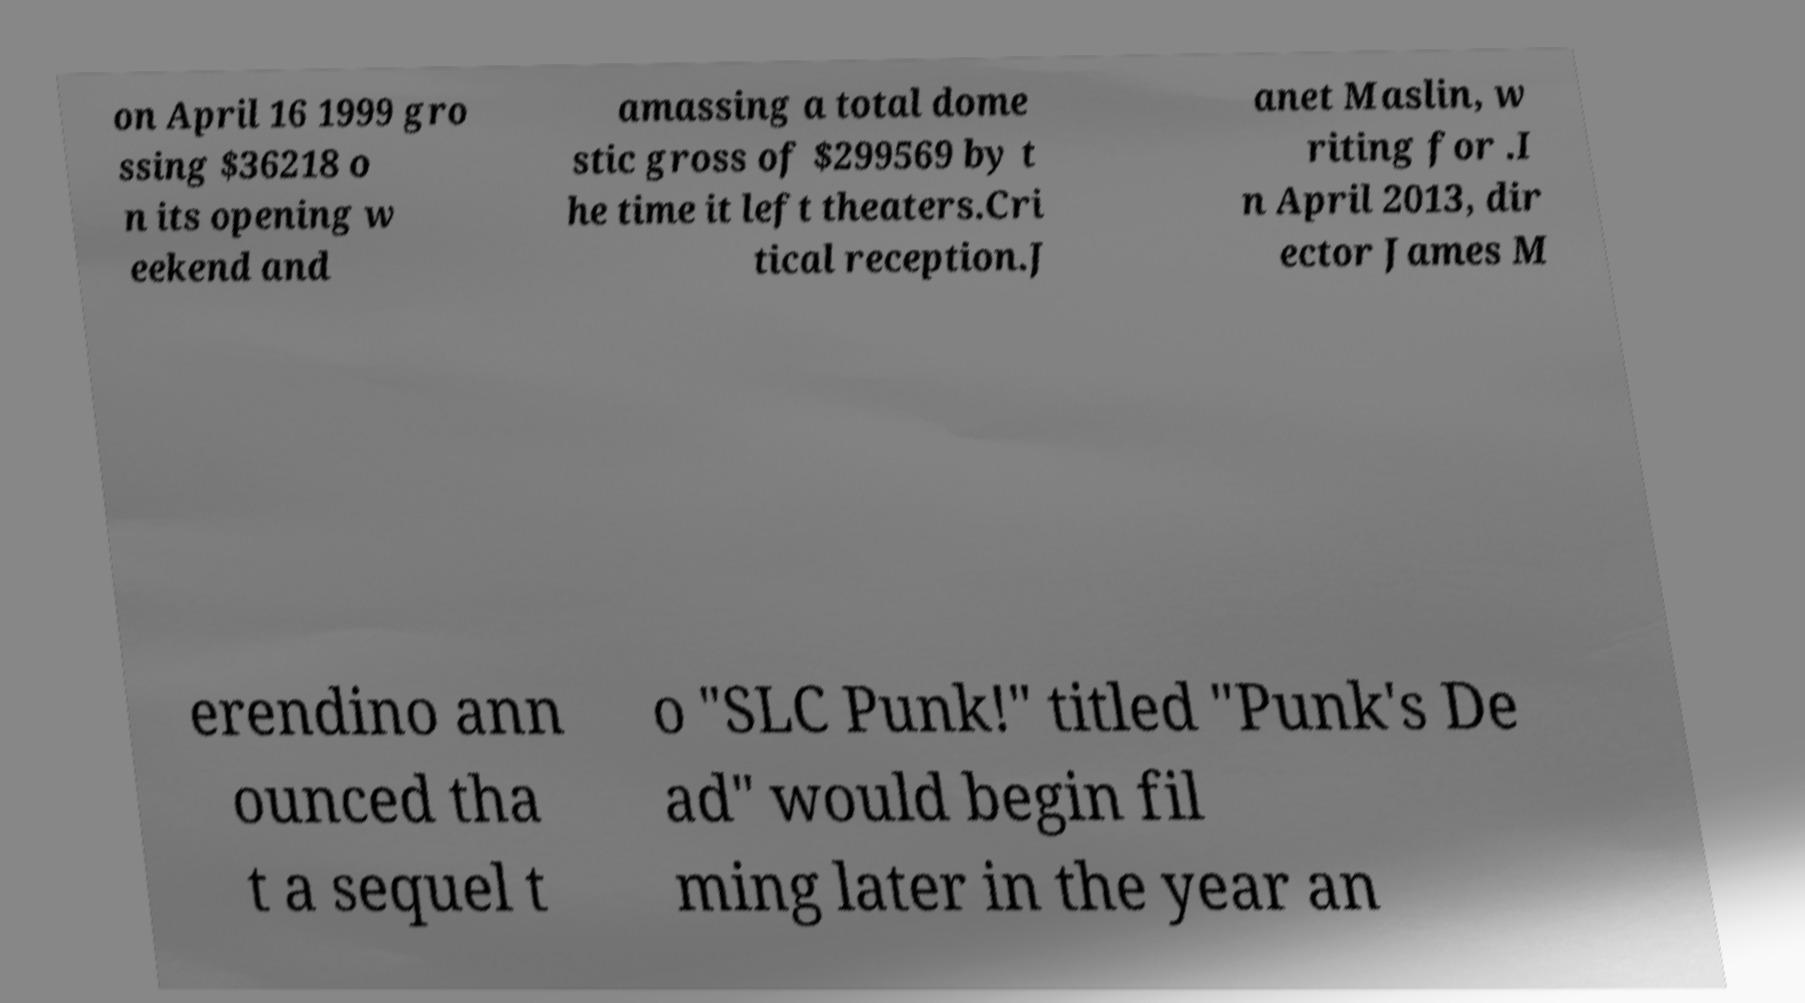What messages or text are displayed in this image? I need them in a readable, typed format. on April 16 1999 gro ssing $36218 o n its opening w eekend and amassing a total dome stic gross of $299569 by t he time it left theaters.Cri tical reception.J anet Maslin, w riting for .I n April 2013, dir ector James M erendino ann ounced tha t a sequel t o "SLC Punk!" titled "Punk's De ad" would begin fil ming later in the year an 